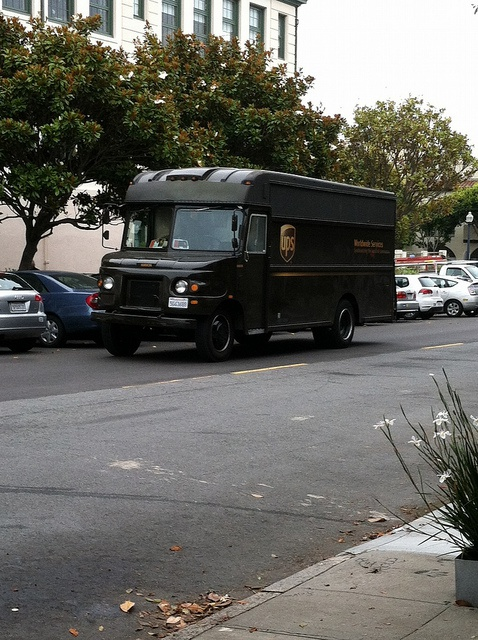Describe the objects in this image and their specific colors. I can see truck in ivory, black, gray, darkgray, and lightgray tones, potted plant in ivory, gray, black, darkgray, and lightgray tones, car in ivory, black, navy, gray, and darkblue tones, car in ivory, black, gray, white, and darkgray tones, and car in ivory, white, black, gray, and darkgray tones in this image. 